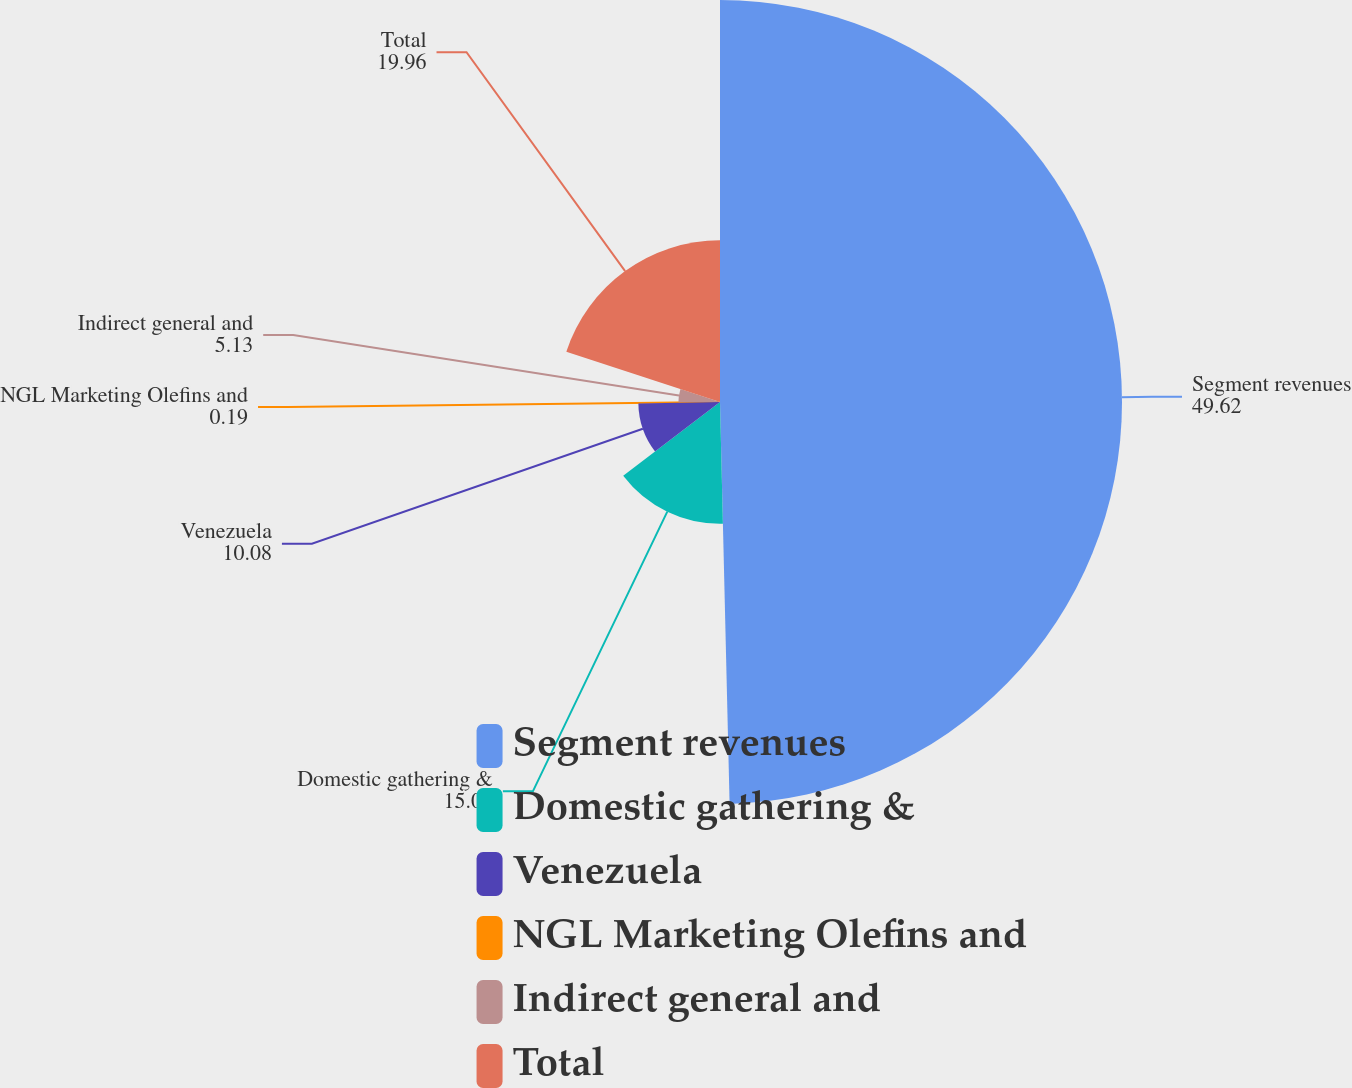Convert chart to OTSL. <chart><loc_0><loc_0><loc_500><loc_500><pie_chart><fcel>Segment revenues<fcel>Domestic gathering &<fcel>Venezuela<fcel>NGL Marketing Olefins and<fcel>Indirect general and<fcel>Total<nl><fcel>49.62%<fcel>15.02%<fcel>10.08%<fcel>0.19%<fcel>5.13%<fcel>19.96%<nl></chart> 